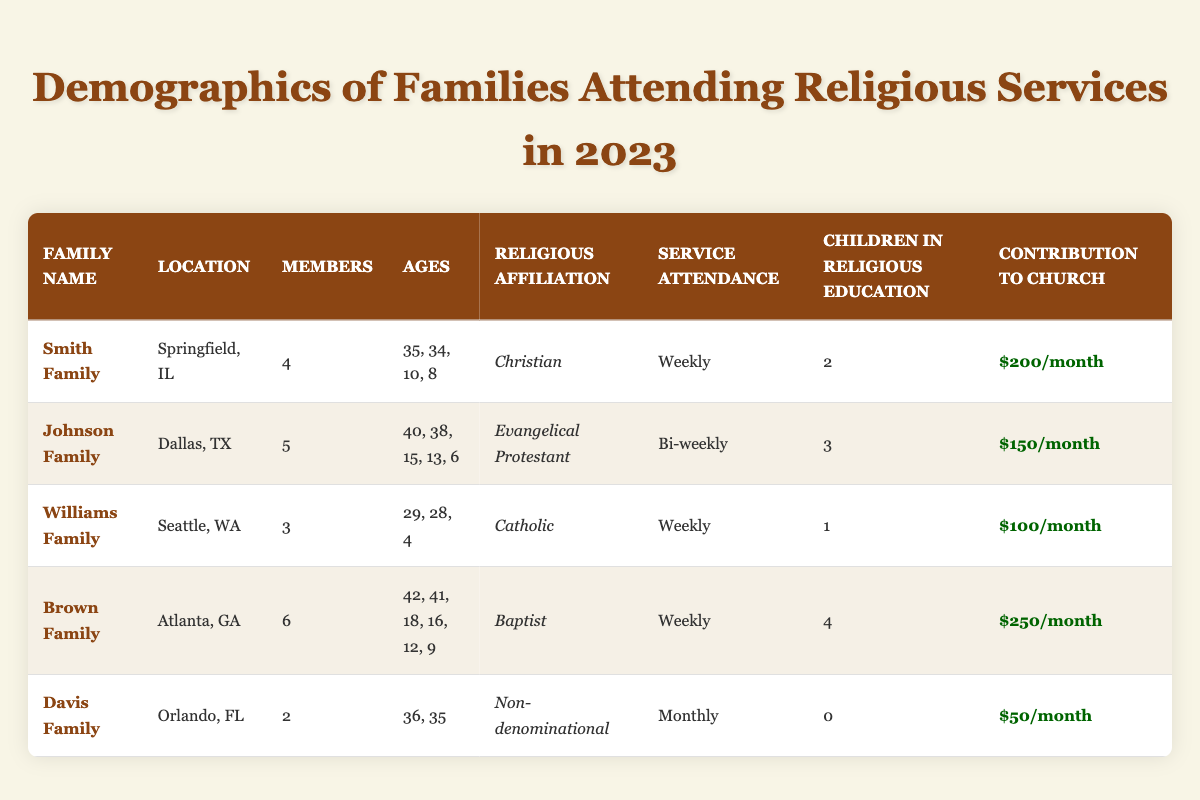What is the religious affiliation of the Smith Family? The Smith Family is listed under the "Religious Affiliation" column in the table, which states they are "Christian."
Answer: Christian How many children are in religious education from the Brown Family? In the table, the Brown Family has "4" children listed under the "Children in Religious Education" column.
Answer: 4 Which family has the highest contribution to the church? By comparing the values in the "Contribution to Church" column, the Brown Family has the highest contribution of "$250/month."
Answer: $250/month What is the average number of members in the families listed? Calculate the average by summing the number of members (4 + 5 + 3 + 6 + 2 = 20) and dividing by the number of families (20/5 = 4).
Answer: 4 Is the Davis Family attending services weekly? The Davis Family's "Service Attendance" is listed as "Monthly," which means they do not attend weekly.
Answer: No How many families are attending services on a weekly basis? The table shows that the Smith, Williams, and Brown Families attend services weekly (3 families). Count these occurrences.
Answer: 3 What is the total number of children in religious education across all families? Sum the children in religious education: 2 (Smith) + 3 (Johnson) + 1 (Williams) + 4 (Brown) + 0 (Davis) = 10 children.
Answer: 10 Which family has the lowest contribution to the church? The contributions listed show the Davis Family with "$50/month," which is the lowest compared to other families.
Answer: $50/month How many family members does the Johnson Family have compared to the Williams Family? The Johnson Family has 5 members, while the Williams Family has 3 members. Compare both values. The difference is 5 - 3 = 2 members.
Answer: 2 members Does any family have all members above 18 years of age? Checking the ages across all families, the Brown Family has members aged 42 and 41, but also has minors, so the answer is no since no family has all members above 18.
Answer: No What percentage of families have children in religious education? There are 5 families total, and 4 of them have children in religious education (Smith, Johnson, Williams, Brown). The percentage is (4/5) * 100 = 80%.
Answer: 80% 